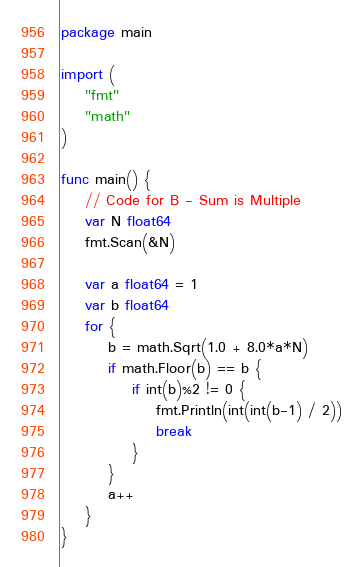<code> <loc_0><loc_0><loc_500><loc_500><_Go_>package main

import (
	"fmt"
	"math"
)

func main() {
	// Code for B - Sum is Multiple
	var N float64
	fmt.Scan(&N)

	var a float64 = 1
	var b float64
	for {
		b = math.Sqrt(1.0 + 8.0*a*N)
		if math.Floor(b) == b {
			if int(b)%2 != 0 {
				fmt.Println(int(int(b-1) / 2))
				break
			}
		}
		a++
	}
}
</code> 